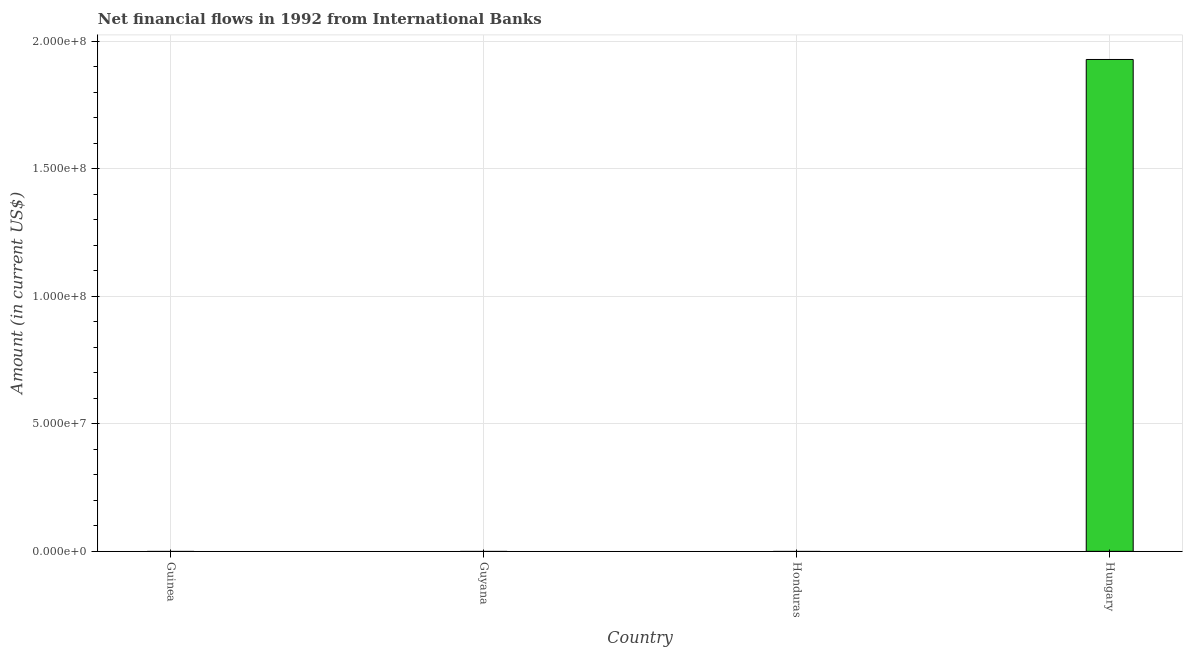What is the title of the graph?
Keep it short and to the point. Net financial flows in 1992 from International Banks. What is the net financial flows from ibrd in Honduras?
Your answer should be compact. 0. Across all countries, what is the maximum net financial flows from ibrd?
Your answer should be compact. 1.93e+08. Across all countries, what is the minimum net financial flows from ibrd?
Your answer should be very brief. 0. In which country was the net financial flows from ibrd maximum?
Your answer should be very brief. Hungary. What is the sum of the net financial flows from ibrd?
Your response must be concise. 1.93e+08. What is the average net financial flows from ibrd per country?
Your answer should be very brief. 4.82e+07. What is the median net financial flows from ibrd?
Your response must be concise. 0. What is the difference between the highest and the lowest net financial flows from ibrd?
Offer a very short reply. 1.93e+08. Are all the bars in the graph horizontal?
Provide a succinct answer. No. What is the difference between two consecutive major ticks on the Y-axis?
Make the answer very short. 5.00e+07. Are the values on the major ticks of Y-axis written in scientific E-notation?
Give a very brief answer. Yes. What is the Amount (in current US$) in Guyana?
Your answer should be compact. 0. What is the Amount (in current US$) in Hungary?
Provide a succinct answer. 1.93e+08. 